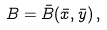Convert formula to latex. <formula><loc_0><loc_0><loc_500><loc_500>B = \bar { B } ( \bar { x } , \bar { y } ) \, ,</formula> 